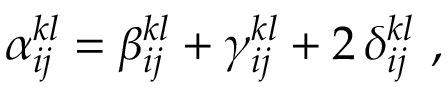<formula> <loc_0><loc_0><loc_500><loc_500>\alpha _ { i j } ^ { k l } = \beta _ { i j } ^ { k l } + \gamma _ { i j } ^ { k l } + 2 \, \delta _ { i j } ^ { k l } ,</formula> 